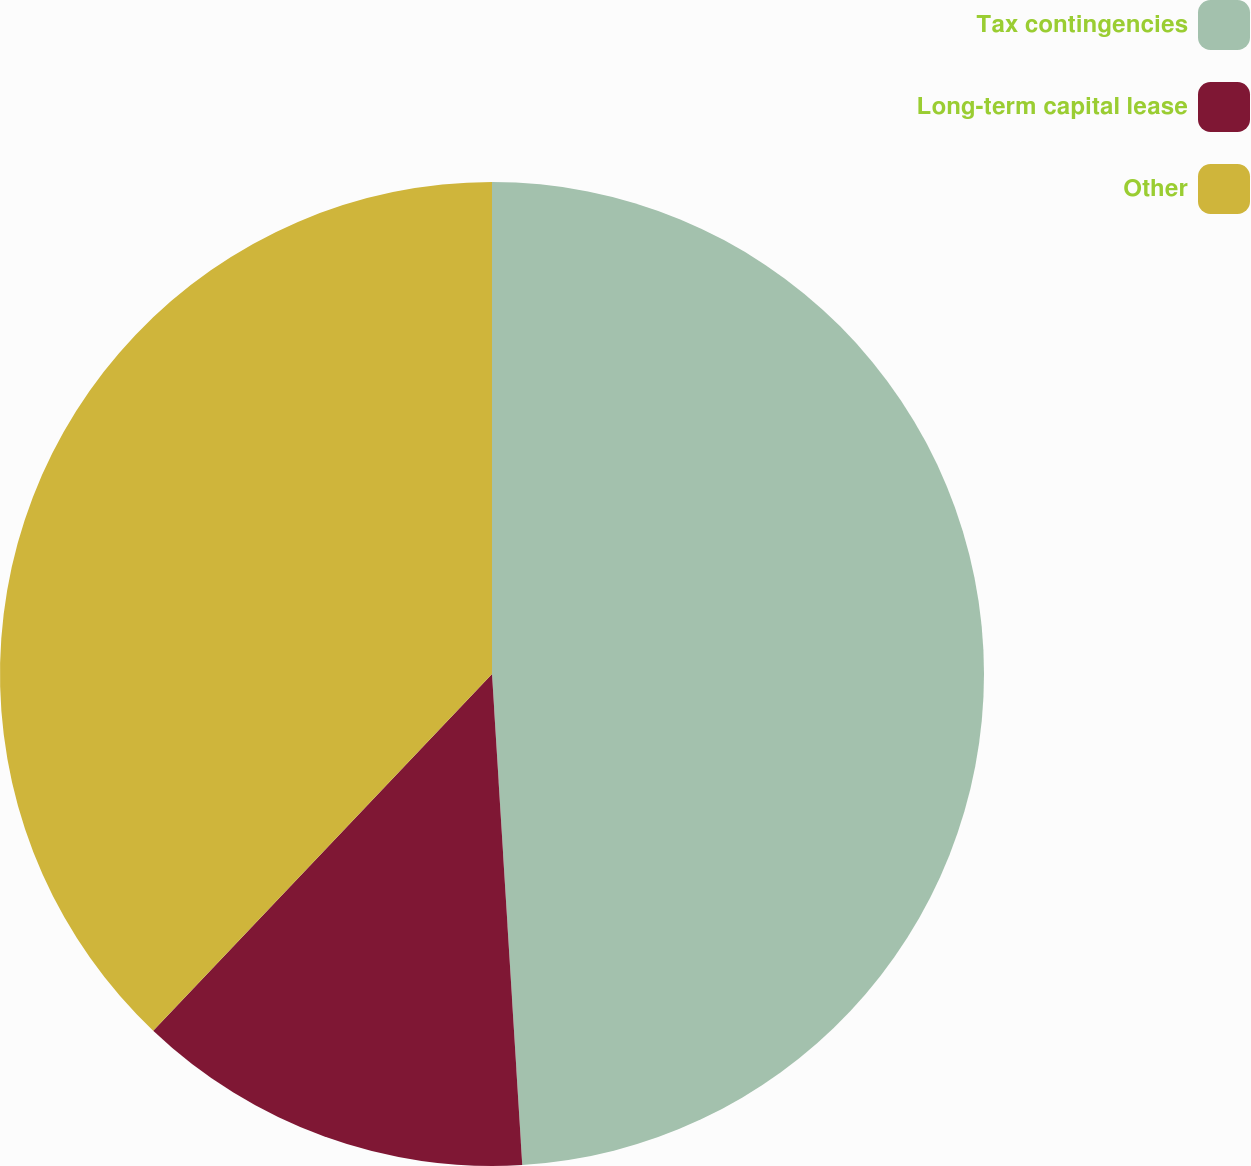<chart> <loc_0><loc_0><loc_500><loc_500><pie_chart><fcel>Tax contingencies<fcel>Long-term capital lease<fcel>Other<nl><fcel>49.02%<fcel>13.07%<fcel>37.91%<nl></chart> 